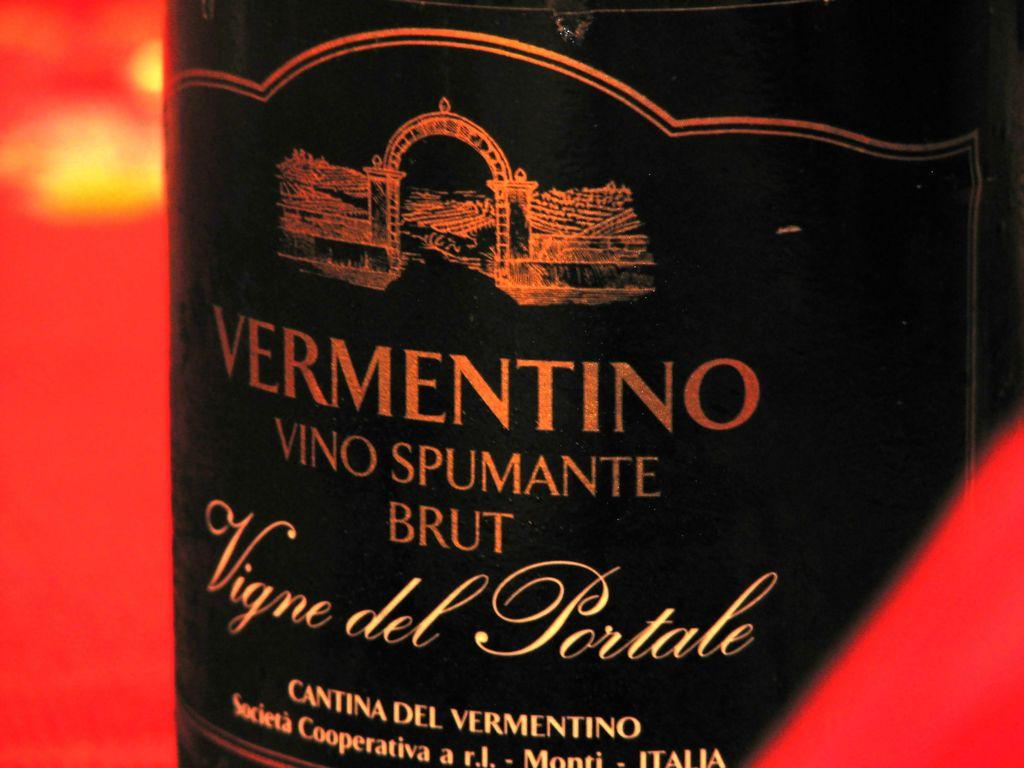<image>
Summarize the visual content of the image. Bottle of wine with a label that says "Vermentino" on it. 